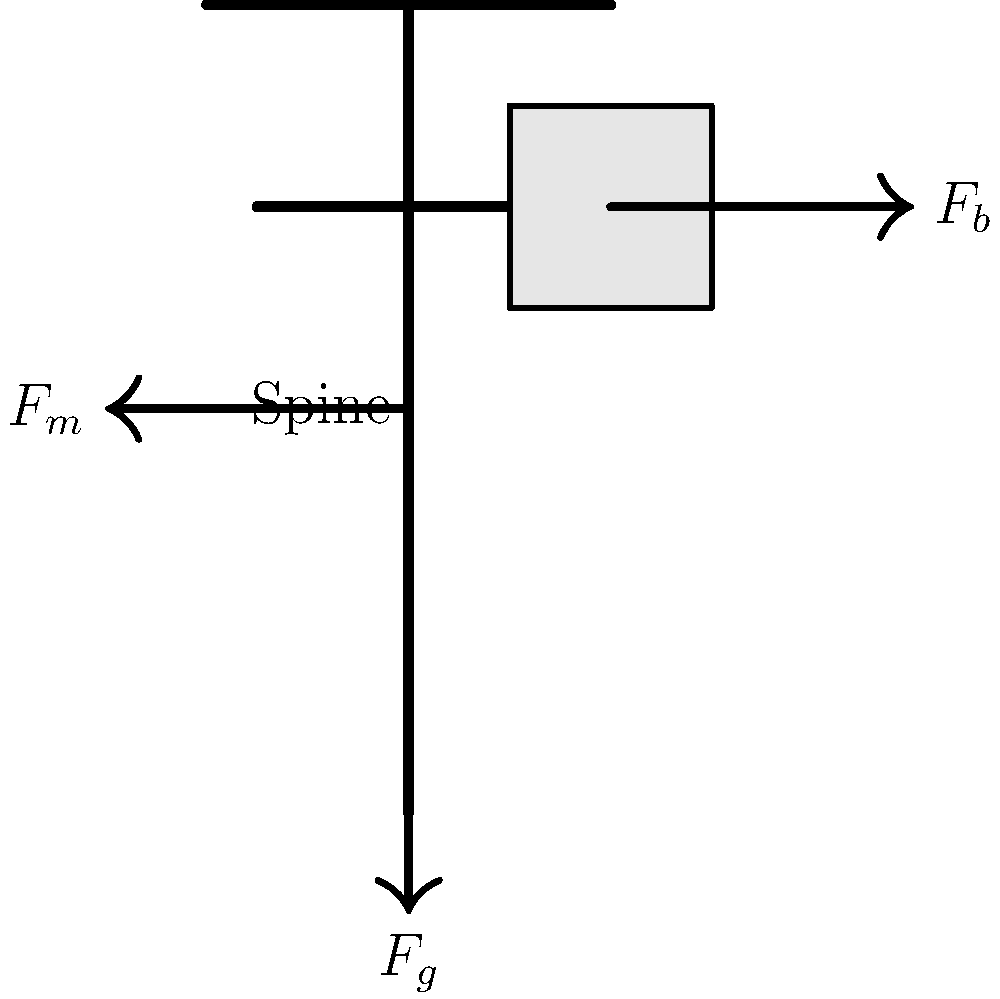As a parent concerned about your child's spinal health, you want to understand the forces acting on their spine when carrying a backpack. In the diagram, $F_b$ represents the force exerted by the backpack, $F_m$ is the muscle force, and $F_g$ is the gravitational force. If the backpack weighs 15 N and your child weighs 400 N, what is the approximate muscle force $F_m$ required to maintain equilibrium, assuming the backpack's center of mass is 20 cm from the spine and the muscles act at a distance of 5 cm from the spine? To solve this problem, we'll use the principle of moments and the conditions for equilibrium. Let's go through this step-by-step:

1) For equilibrium, the sum of all moments about any point should be zero. Let's choose the base of the spine as our point of reference.

2) The gravitational force $F_g$ acts through the center of the spine, so it doesn't create a moment.

3) The backpack force $F_b$ creates a clockwise moment:
   $M_b = F_b \times d_b = 15 \text{ N} \times 0.20 \text{ m} = 3 \text{ Nm}$

4) The muscle force $F_m$ creates a counterclockwise moment to balance this:
   $M_m = F_m \times d_m = F_m \times 0.05 \text{ m}$

5) For equilibrium: $M_b = M_m$
   $3 \text{ Nm} = F_m \times 0.05 \text{ m}$

6) Solving for $F_m$:
   $F_m = \frac{3 \text{ Nm}}{0.05 \text{ m}} = 60 \text{ N}$

Therefore, the muscle force required to maintain equilibrium is approximately 60 N.

This demonstrates the significant force the back muscles must exert to counteract even a relatively light backpack, highlighting the importance of proper backpack use and weight distribution for spinal health.
Answer: 60 N 